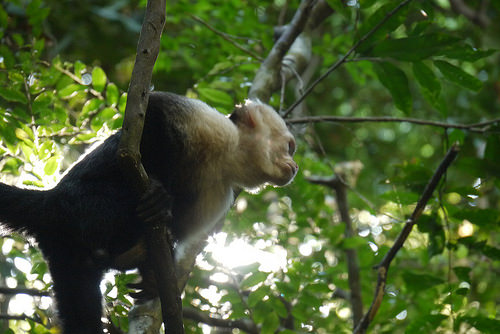<image>
Is the monkey on the tree? Yes. Looking at the image, I can see the monkey is positioned on top of the tree, with the tree providing support. Where is the monkey in relation to the tree? Is it under the tree? Yes. The monkey is positioned underneath the tree, with the tree above it in the vertical space. Is the monkey in the tree? Yes. The monkey is contained within or inside the tree, showing a containment relationship. 